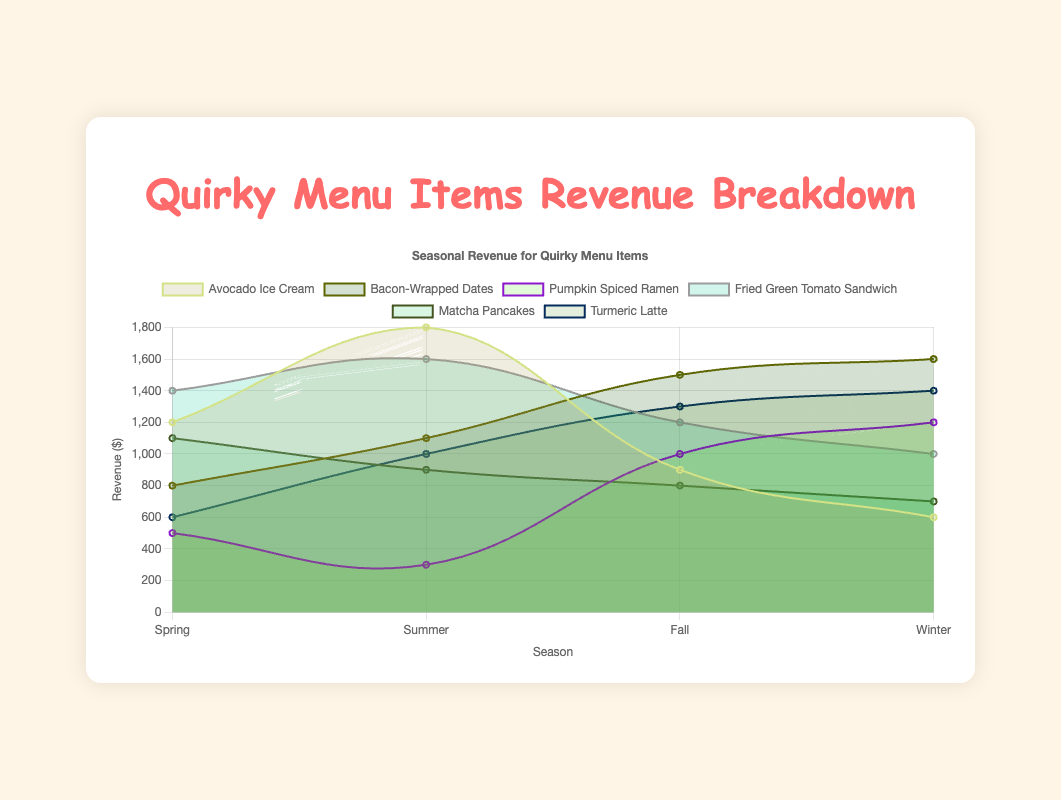What is the revenue for "Avocado Ice Cream" in Summer? The revenue for "Avocado Ice Cream" in the Summer can be identified by finding the corresponding point in the Summer column for this item. The figure shows it to be 1800.
Answer: 1800 Which season had the highest total revenue for "Bacon-Wrapped Dates"? To find the season with the highest total revenue for "Bacon-Wrapped Dates," we compare the values in each season: Spring (800), Summer (1100), Fall (1500), and Winter (1600). Winter has the highest revenue.
Answer: Winter What is the sum of the revenue for "Pumpkin Spiced Ramen" in Spring and Summer? The spring revenue for "Pumpkin Spiced Ramen" is 500, and the summer revenue is 300. Adding them together gives 500 + 300 = 800.
Answer: 800 Which menu item had the lowest revenue in Winter? To determine the lowest revenue in Winter, compare the winter values of all items: Avocado Ice Cream (600), Bacon-Wrapped Dates (1600), Pumpkin Spiced Ramen (1200), Fried Green Tomato Sandwich (1000), Matcha Pancakes (700), and Turmeric Latte (1400). Avocado Ice Cream has the lowest revenue.
Answer: Avocado Ice Cream Between which seasons does "Fried Green Tomato Sandwich" see the largest increase in revenue? To find the largest increase, calculate the revenue differences between consecutive seasons for "Fried Green Tomato Sandwich": Spring to Summer (1600 - 1400 = 200), Summer to Fall (1200 - 1600 = -400), and Fall to Winter (1000 - 1200 = -200). The most significant positive change is from Spring to Summer.
Answer: Spring to Summer Which item consistently has decreasing revenue from season to season? We look for the item whose revenue decreases each season: "Matcha Pancakes" has the revenue pattern Spring (1100), Summer (900), Fall (800), Winter (700), which consistently decreases.
Answer: Matcha Pancakes What is the average revenue of "Turmeric Latte" across all seasons? The revenues for "Turmeric Latte" are 600 (Spring), 1000 (Summer), 1300 (Fall), and 1400 (Winter). The average is calculated as (600 + 1000 + 1300 + 1400) / 4 = 1050.
Answer: 1050 